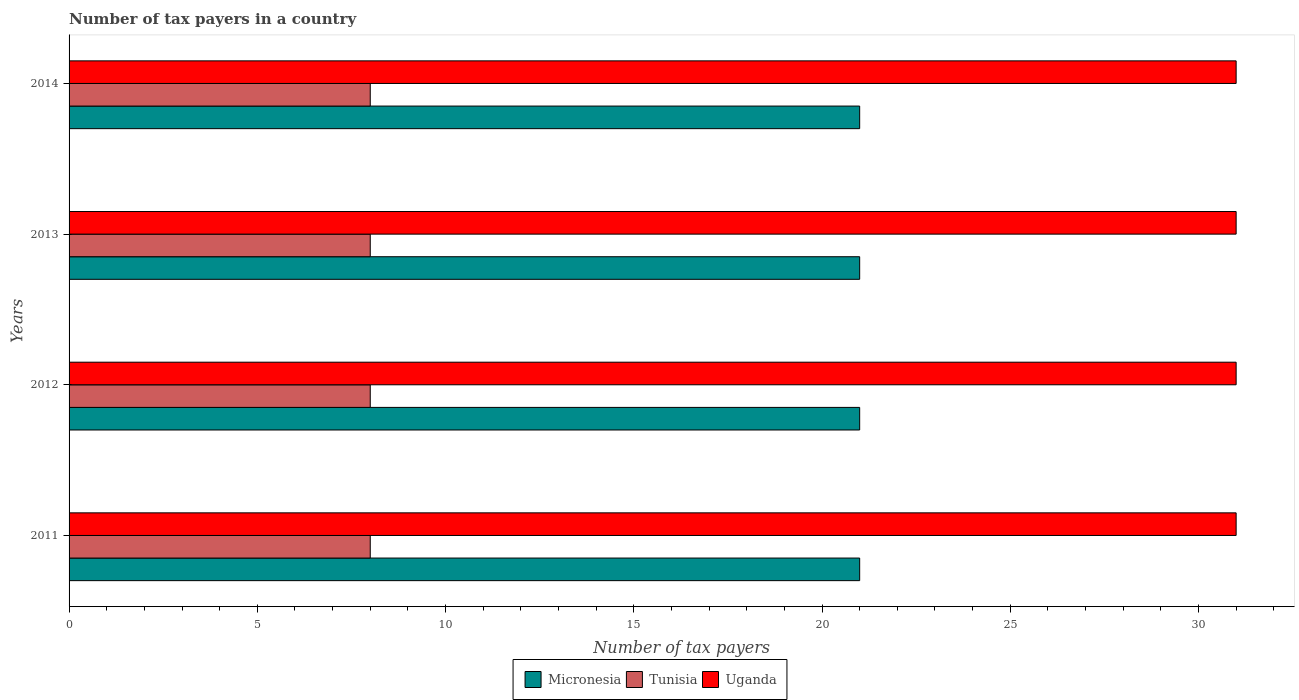Are the number of bars on each tick of the Y-axis equal?
Provide a succinct answer. Yes. What is the label of the 4th group of bars from the top?
Keep it short and to the point. 2011. What is the number of tax payers in in Micronesia in 2011?
Give a very brief answer. 21. Across all years, what is the maximum number of tax payers in in Uganda?
Provide a succinct answer. 31. Across all years, what is the minimum number of tax payers in in Tunisia?
Provide a succinct answer. 8. In which year was the number of tax payers in in Uganda maximum?
Give a very brief answer. 2011. What is the total number of tax payers in in Micronesia in the graph?
Provide a short and direct response. 84. What is the difference between the number of tax payers in in Tunisia in 2011 and the number of tax payers in in Micronesia in 2012?
Ensure brevity in your answer.  -13. In the year 2012, what is the difference between the number of tax payers in in Micronesia and number of tax payers in in Tunisia?
Your response must be concise. 13. Is the number of tax payers in in Tunisia in 2012 less than that in 2014?
Give a very brief answer. No. Is the difference between the number of tax payers in in Micronesia in 2011 and 2014 greater than the difference between the number of tax payers in in Tunisia in 2011 and 2014?
Offer a terse response. No. In how many years, is the number of tax payers in in Uganda greater than the average number of tax payers in in Uganda taken over all years?
Ensure brevity in your answer.  0. What does the 3rd bar from the top in 2012 represents?
Provide a succinct answer. Micronesia. What does the 1st bar from the bottom in 2014 represents?
Keep it short and to the point. Micronesia. Are all the bars in the graph horizontal?
Provide a short and direct response. Yes. How many years are there in the graph?
Make the answer very short. 4. What is the difference between two consecutive major ticks on the X-axis?
Your response must be concise. 5. Does the graph contain grids?
Provide a succinct answer. No. Where does the legend appear in the graph?
Your answer should be very brief. Bottom center. How many legend labels are there?
Offer a very short reply. 3. How are the legend labels stacked?
Provide a short and direct response. Horizontal. What is the title of the graph?
Give a very brief answer. Number of tax payers in a country. What is the label or title of the X-axis?
Your response must be concise. Number of tax payers. What is the Number of tax payers of Micronesia in 2011?
Give a very brief answer. 21. What is the Number of tax payers in Tunisia in 2011?
Make the answer very short. 8. What is the Number of tax payers in Micronesia in 2012?
Provide a short and direct response. 21. What is the Number of tax payers in Tunisia in 2012?
Offer a very short reply. 8. What is the Number of tax payers in Uganda in 2012?
Your answer should be compact. 31. What is the Number of tax payers in Micronesia in 2013?
Ensure brevity in your answer.  21. What is the Number of tax payers in Tunisia in 2013?
Give a very brief answer. 8. What is the Number of tax payers of Uganda in 2013?
Your answer should be very brief. 31. What is the Number of tax payers of Uganda in 2014?
Your response must be concise. 31. Across all years, what is the minimum Number of tax payers in Tunisia?
Provide a succinct answer. 8. What is the total Number of tax payers in Micronesia in the graph?
Provide a succinct answer. 84. What is the total Number of tax payers in Tunisia in the graph?
Offer a terse response. 32. What is the total Number of tax payers in Uganda in the graph?
Offer a terse response. 124. What is the difference between the Number of tax payers in Micronesia in 2011 and that in 2012?
Offer a very short reply. 0. What is the difference between the Number of tax payers in Micronesia in 2011 and that in 2013?
Offer a terse response. 0. What is the difference between the Number of tax payers in Tunisia in 2011 and that in 2013?
Your answer should be very brief. 0. What is the difference between the Number of tax payers in Uganda in 2011 and that in 2013?
Your answer should be very brief. 0. What is the difference between the Number of tax payers of Micronesia in 2011 and that in 2014?
Offer a terse response. 0. What is the difference between the Number of tax payers in Tunisia in 2011 and that in 2014?
Offer a very short reply. 0. What is the difference between the Number of tax payers in Uganda in 2012 and that in 2013?
Offer a terse response. 0. What is the difference between the Number of tax payers in Micronesia in 2012 and that in 2014?
Your answer should be very brief. 0. What is the difference between the Number of tax payers in Tunisia in 2012 and that in 2014?
Your response must be concise. 0. What is the difference between the Number of tax payers in Uganda in 2012 and that in 2014?
Provide a succinct answer. 0. What is the difference between the Number of tax payers in Tunisia in 2013 and that in 2014?
Make the answer very short. 0. What is the difference between the Number of tax payers in Uganda in 2013 and that in 2014?
Provide a succinct answer. 0. What is the difference between the Number of tax payers in Micronesia in 2011 and the Number of tax payers in Tunisia in 2012?
Provide a succinct answer. 13. What is the difference between the Number of tax payers in Micronesia in 2011 and the Number of tax payers in Uganda in 2012?
Give a very brief answer. -10. What is the difference between the Number of tax payers in Micronesia in 2011 and the Number of tax payers in Uganda in 2013?
Your response must be concise. -10. What is the difference between the Number of tax payers of Tunisia in 2011 and the Number of tax payers of Uganda in 2013?
Provide a succinct answer. -23. What is the difference between the Number of tax payers of Micronesia in 2011 and the Number of tax payers of Tunisia in 2014?
Offer a terse response. 13. What is the difference between the Number of tax payers of Micronesia in 2011 and the Number of tax payers of Uganda in 2014?
Offer a very short reply. -10. What is the difference between the Number of tax payers in Tunisia in 2011 and the Number of tax payers in Uganda in 2014?
Offer a terse response. -23. What is the difference between the Number of tax payers of Micronesia in 2012 and the Number of tax payers of Tunisia in 2014?
Your answer should be compact. 13. What is the difference between the Number of tax payers of Micronesia in 2012 and the Number of tax payers of Uganda in 2014?
Offer a very short reply. -10. What is the difference between the Number of tax payers in Tunisia in 2012 and the Number of tax payers in Uganda in 2014?
Keep it short and to the point. -23. What is the average Number of tax payers in Tunisia per year?
Ensure brevity in your answer.  8. In the year 2011, what is the difference between the Number of tax payers in Tunisia and Number of tax payers in Uganda?
Offer a terse response. -23. In the year 2012, what is the difference between the Number of tax payers in Micronesia and Number of tax payers in Tunisia?
Your answer should be very brief. 13. In the year 2012, what is the difference between the Number of tax payers in Tunisia and Number of tax payers in Uganda?
Provide a succinct answer. -23. In the year 2013, what is the difference between the Number of tax payers of Micronesia and Number of tax payers of Tunisia?
Offer a terse response. 13. In the year 2013, what is the difference between the Number of tax payers of Tunisia and Number of tax payers of Uganda?
Keep it short and to the point. -23. In the year 2014, what is the difference between the Number of tax payers in Micronesia and Number of tax payers in Tunisia?
Keep it short and to the point. 13. In the year 2014, what is the difference between the Number of tax payers in Micronesia and Number of tax payers in Uganda?
Offer a very short reply. -10. In the year 2014, what is the difference between the Number of tax payers in Tunisia and Number of tax payers in Uganda?
Keep it short and to the point. -23. What is the ratio of the Number of tax payers in Micronesia in 2011 to that in 2012?
Offer a very short reply. 1. What is the ratio of the Number of tax payers of Tunisia in 2011 to that in 2012?
Your answer should be very brief. 1. What is the ratio of the Number of tax payers in Uganda in 2011 to that in 2013?
Ensure brevity in your answer.  1. What is the ratio of the Number of tax payers in Micronesia in 2011 to that in 2014?
Provide a short and direct response. 1. What is the ratio of the Number of tax payers of Tunisia in 2011 to that in 2014?
Ensure brevity in your answer.  1. What is the ratio of the Number of tax payers of Uganda in 2011 to that in 2014?
Ensure brevity in your answer.  1. What is the ratio of the Number of tax payers of Tunisia in 2012 to that in 2013?
Keep it short and to the point. 1. What is the ratio of the Number of tax payers of Uganda in 2012 to that in 2013?
Offer a terse response. 1. What is the ratio of the Number of tax payers in Tunisia in 2012 to that in 2014?
Provide a succinct answer. 1. What is the ratio of the Number of tax payers in Micronesia in 2013 to that in 2014?
Keep it short and to the point. 1. What is the ratio of the Number of tax payers of Tunisia in 2013 to that in 2014?
Offer a very short reply. 1. What is the ratio of the Number of tax payers in Uganda in 2013 to that in 2014?
Your response must be concise. 1. What is the difference between the highest and the lowest Number of tax payers of Micronesia?
Your response must be concise. 0. What is the difference between the highest and the lowest Number of tax payers of Uganda?
Your answer should be very brief. 0. 